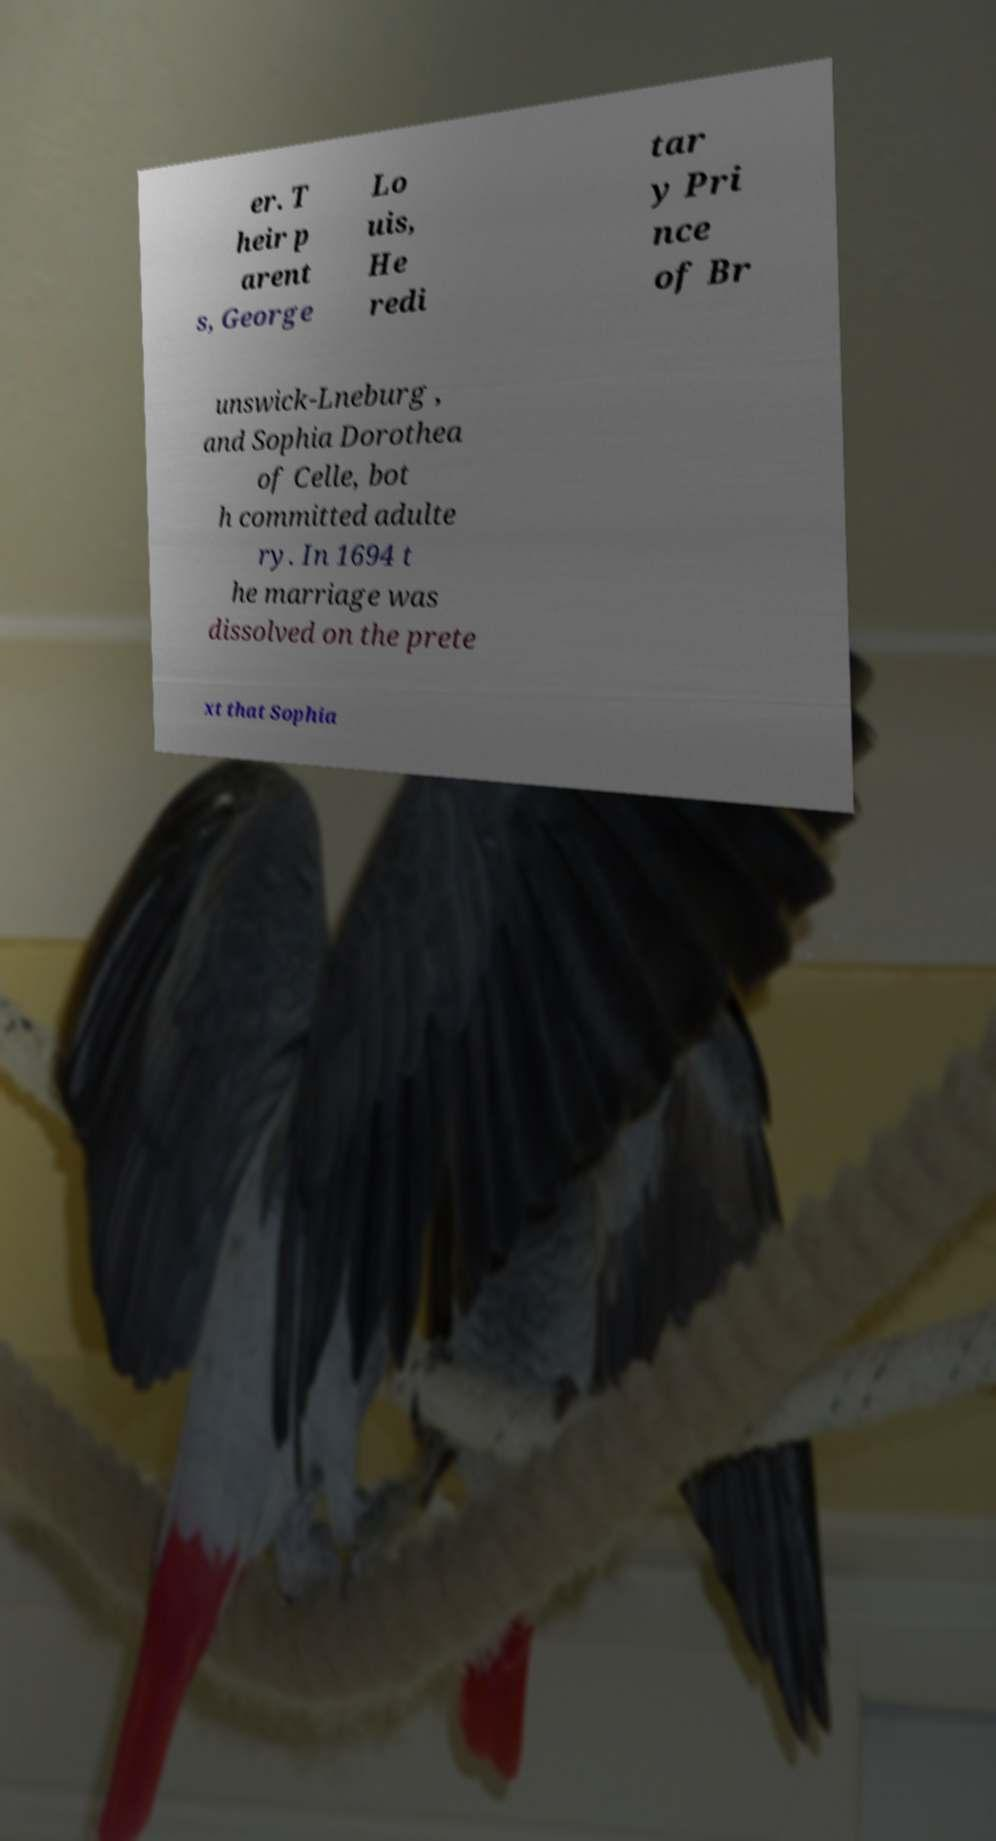Can you accurately transcribe the text from the provided image for me? er. T heir p arent s, George Lo uis, He redi tar y Pri nce of Br unswick-Lneburg , and Sophia Dorothea of Celle, bot h committed adulte ry. In 1694 t he marriage was dissolved on the prete xt that Sophia 